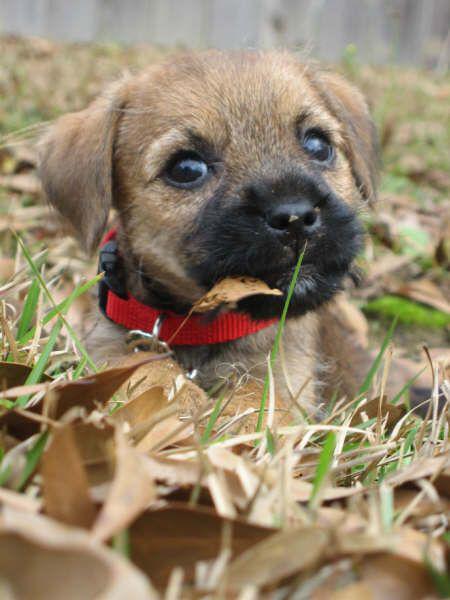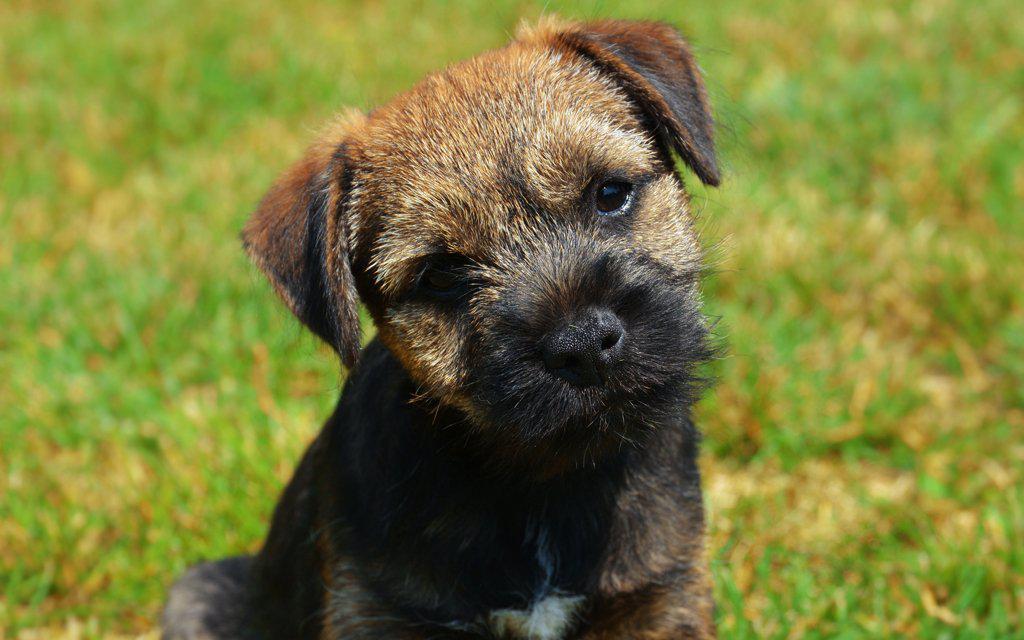The first image is the image on the left, the second image is the image on the right. Evaluate the accuracy of this statement regarding the images: "Both puppies are in green grass with no collar visible.". Is it true? Answer yes or no. No. The first image is the image on the left, the second image is the image on the right. Considering the images on both sides, is "A puppy runs in the grass toward the photographer." valid? Answer yes or no. No. 